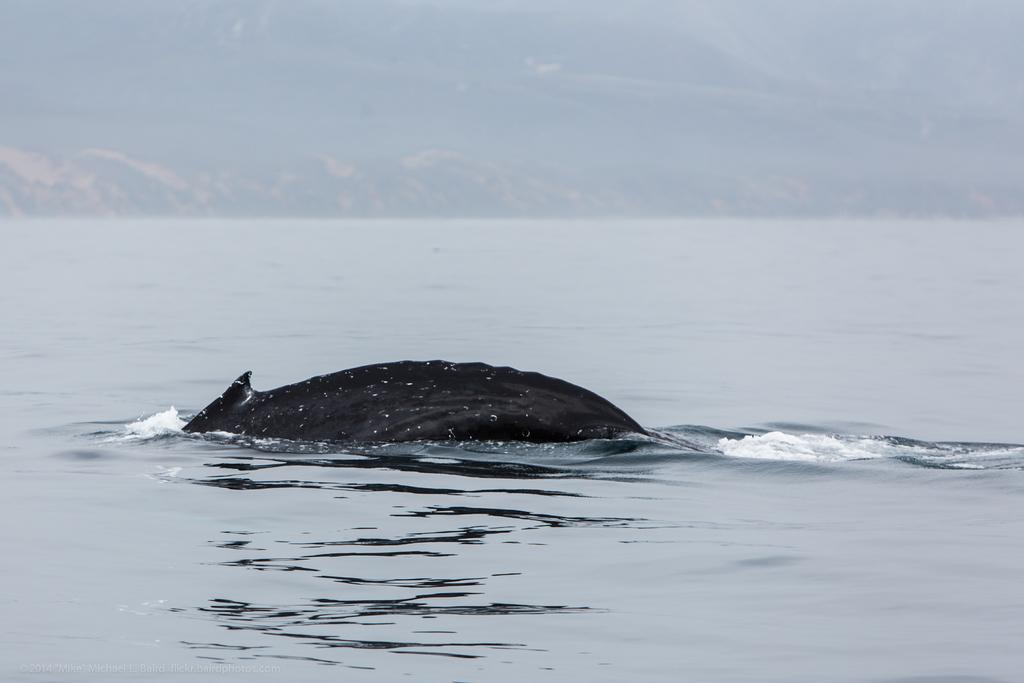What type of animal can be seen in the image? There is a water animal in the image. Where is the water animal located? The water animal is in the water. Can you describe the background of the image? The background of the image is not clear. What type of hope is being exchanged between the water animal and the background in the image? There is no exchange of hope or any other abstract concept in the image, as it features a water animal in the water with an unclear background. 